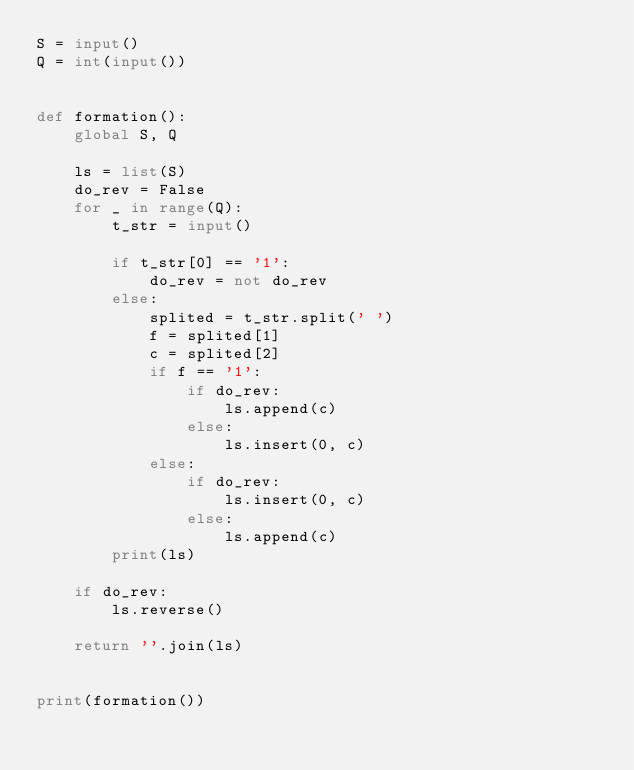<code> <loc_0><loc_0><loc_500><loc_500><_Python_>S = input()
Q = int(input())


def formation():
    global S, Q

    ls = list(S)
    do_rev = False
    for _ in range(Q):
        t_str = input()

        if t_str[0] == '1':
            do_rev = not do_rev
        else:
            splited = t_str.split(' ')
            f = splited[1]
            c = splited[2]
            if f == '1':
                if do_rev:
                    ls.append(c)
                else:
                    ls.insert(0, c)
            else:
                if do_rev:
                    ls.insert(0, c)
                else:
                    ls.append(c)
        print(ls)

    if do_rev:
        ls.reverse()

    return ''.join(ls)


print(formation())
</code> 